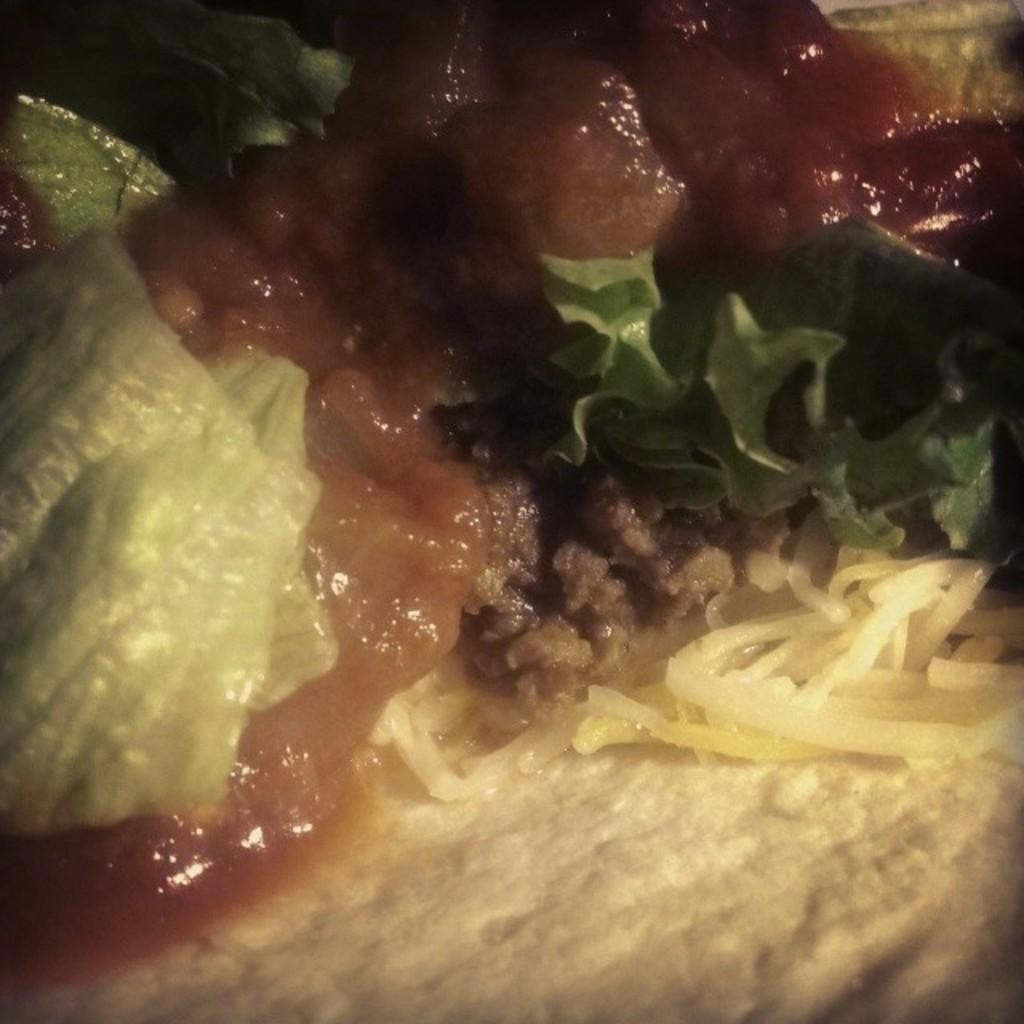Describe this image in one or two sentences. In this image we can see food. 